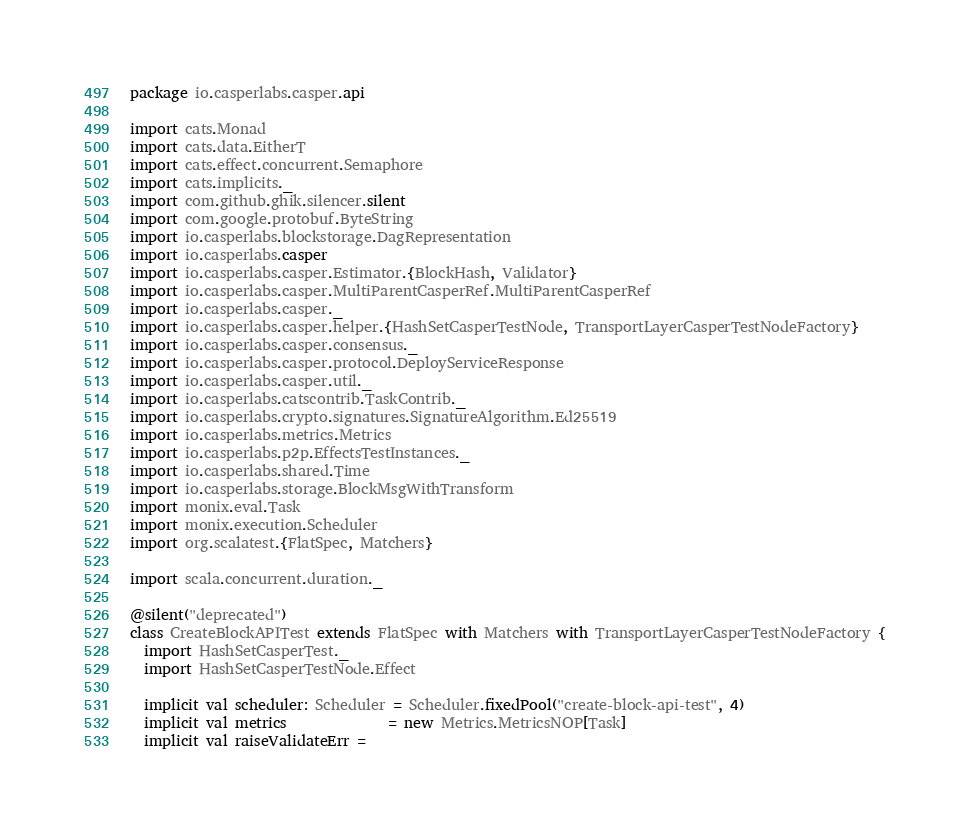<code> <loc_0><loc_0><loc_500><loc_500><_Scala_>package io.casperlabs.casper.api

import cats.Monad
import cats.data.EitherT
import cats.effect.concurrent.Semaphore
import cats.implicits._
import com.github.ghik.silencer.silent
import com.google.protobuf.ByteString
import io.casperlabs.blockstorage.DagRepresentation
import io.casperlabs.casper
import io.casperlabs.casper.Estimator.{BlockHash, Validator}
import io.casperlabs.casper.MultiParentCasperRef.MultiParentCasperRef
import io.casperlabs.casper._
import io.casperlabs.casper.helper.{HashSetCasperTestNode, TransportLayerCasperTestNodeFactory}
import io.casperlabs.casper.consensus._
import io.casperlabs.casper.protocol.DeployServiceResponse
import io.casperlabs.casper.util._
import io.casperlabs.catscontrib.TaskContrib._
import io.casperlabs.crypto.signatures.SignatureAlgorithm.Ed25519
import io.casperlabs.metrics.Metrics
import io.casperlabs.p2p.EffectsTestInstances._
import io.casperlabs.shared.Time
import io.casperlabs.storage.BlockMsgWithTransform
import monix.eval.Task
import monix.execution.Scheduler
import org.scalatest.{FlatSpec, Matchers}

import scala.concurrent.duration._

@silent("deprecated")
class CreateBlockAPITest extends FlatSpec with Matchers with TransportLayerCasperTestNodeFactory {
  import HashSetCasperTest._
  import HashSetCasperTestNode.Effect

  implicit val scheduler: Scheduler = Scheduler.fixedPool("create-block-api-test", 4)
  implicit val metrics              = new Metrics.MetricsNOP[Task]
  implicit val raiseValidateErr =</code> 